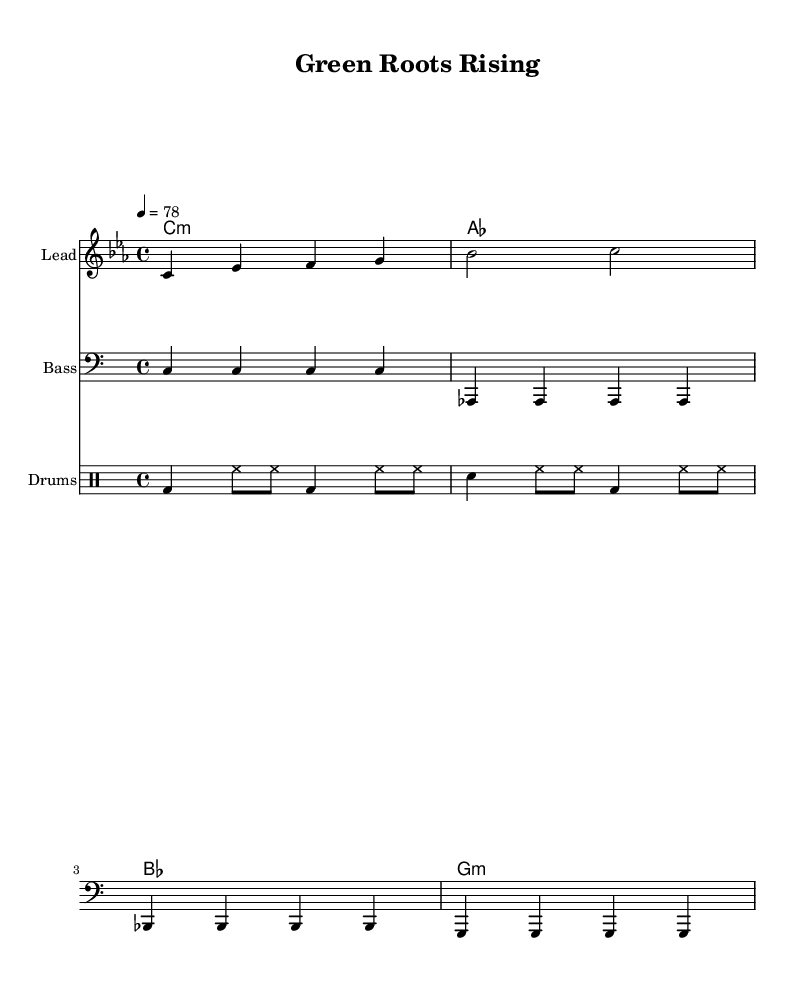What is the key signature of this music? The key signature is C minor, which has three flats: B flat, E flat, and A flat. This is determined by observing the key signature section of the sheet music.
Answer: C minor What is the time signature of this piece? The time signature is indicated at the beginning of the score, showing that there are four beats per measure and each quarter note receives one beat. This implies a standard 4/4 time signature.
Answer: 4/4 What is the tempo marking for this music? The tempo marking is found at the beginning of the score, indicating that the piece should be played at a speed of 78 beats per minute. This specifies the pace for performing the song.
Answer: 78 How many measures are in the melody? The melody section consists of four measures as seen by counting the individual segments of music, which are traditionally marked by vertical lines in the sheet music. Each segment represents one measure.
Answer: 4 What type of musical genre does this sheet music represent? The sheet music is specified as "Reggae" in the introduction, and this genre is characterized by its offbeat rhythms and socially conscious lyrics.
Answer: Reggae What is the primary theme expressed in the lyrics? The lyrics are focused on "Green roots" which imply themes of environmental awareness and sustainability. The phrase suggests a connection to nature and reflects a common theme in conscious reggae music.
Answer: Environmental awareness 